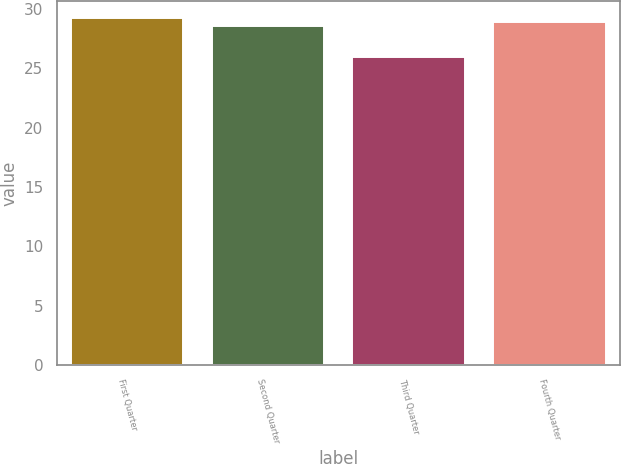<chart> <loc_0><loc_0><loc_500><loc_500><bar_chart><fcel>First Quarter<fcel>Second Quarter<fcel>Third Quarter<fcel>Fourth Quarter<nl><fcel>29.22<fcel>28.6<fcel>26<fcel>28.91<nl></chart> 